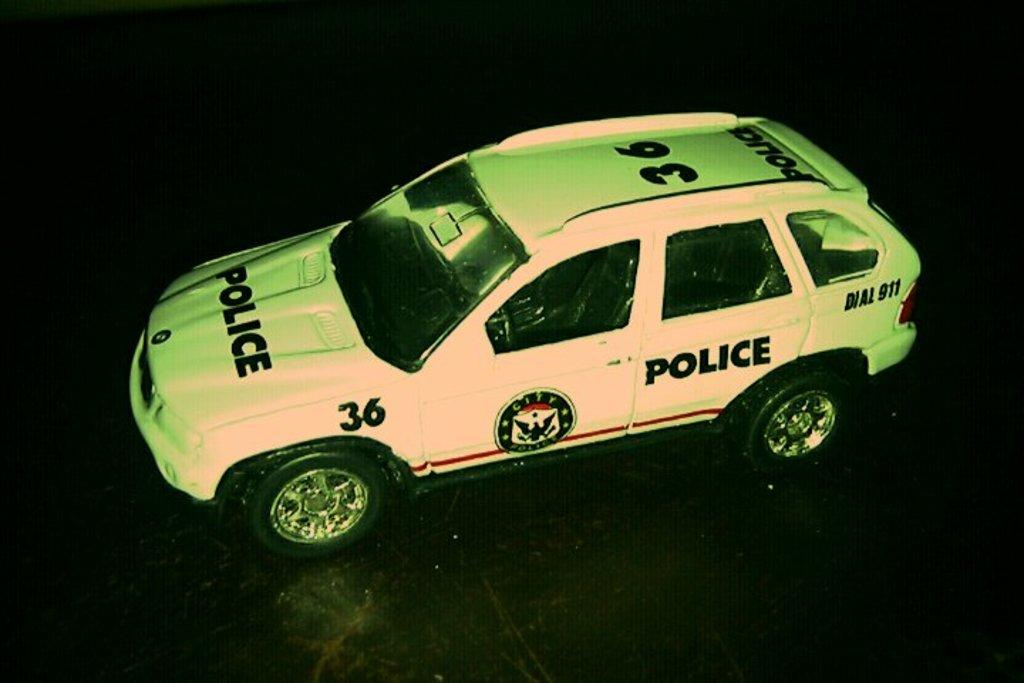What type of vehicle is present in the image? There is a police vehicle in the image. Where is the police vehicle located? The police vehicle is on the floor. Are the pigs driving the police vehicle in the image? There are no pigs present in the image, and the police vehicle is stationary on the floor. 